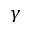<formula> <loc_0><loc_0><loc_500><loc_500>\gamma</formula> 